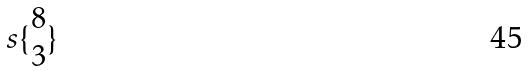<formula> <loc_0><loc_0><loc_500><loc_500>s \{ \begin{matrix} 8 \\ 3 \end{matrix} \}</formula> 